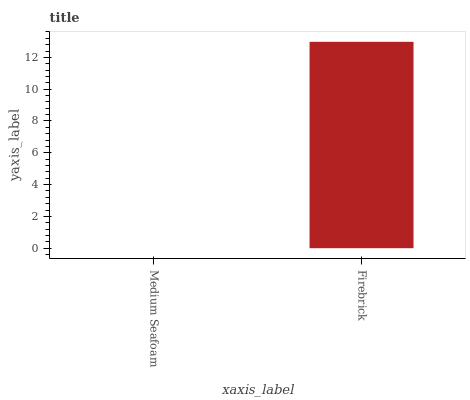Is Medium Seafoam the minimum?
Answer yes or no. Yes. Is Firebrick the maximum?
Answer yes or no. Yes. Is Firebrick the minimum?
Answer yes or no. No. Is Firebrick greater than Medium Seafoam?
Answer yes or no. Yes. Is Medium Seafoam less than Firebrick?
Answer yes or no. Yes. Is Medium Seafoam greater than Firebrick?
Answer yes or no. No. Is Firebrick less than Medium Seafoam?
Answer yes or no. No. Is Firebrick the high median?
Answer yes or no. Yes. Is Medium Seafoam the low median?
Answer yes or no. Yes. Is Medium Seafoam the high median?
Answer yes or no. No. Is Firebrick the low median?
Answer yes or no. No. 